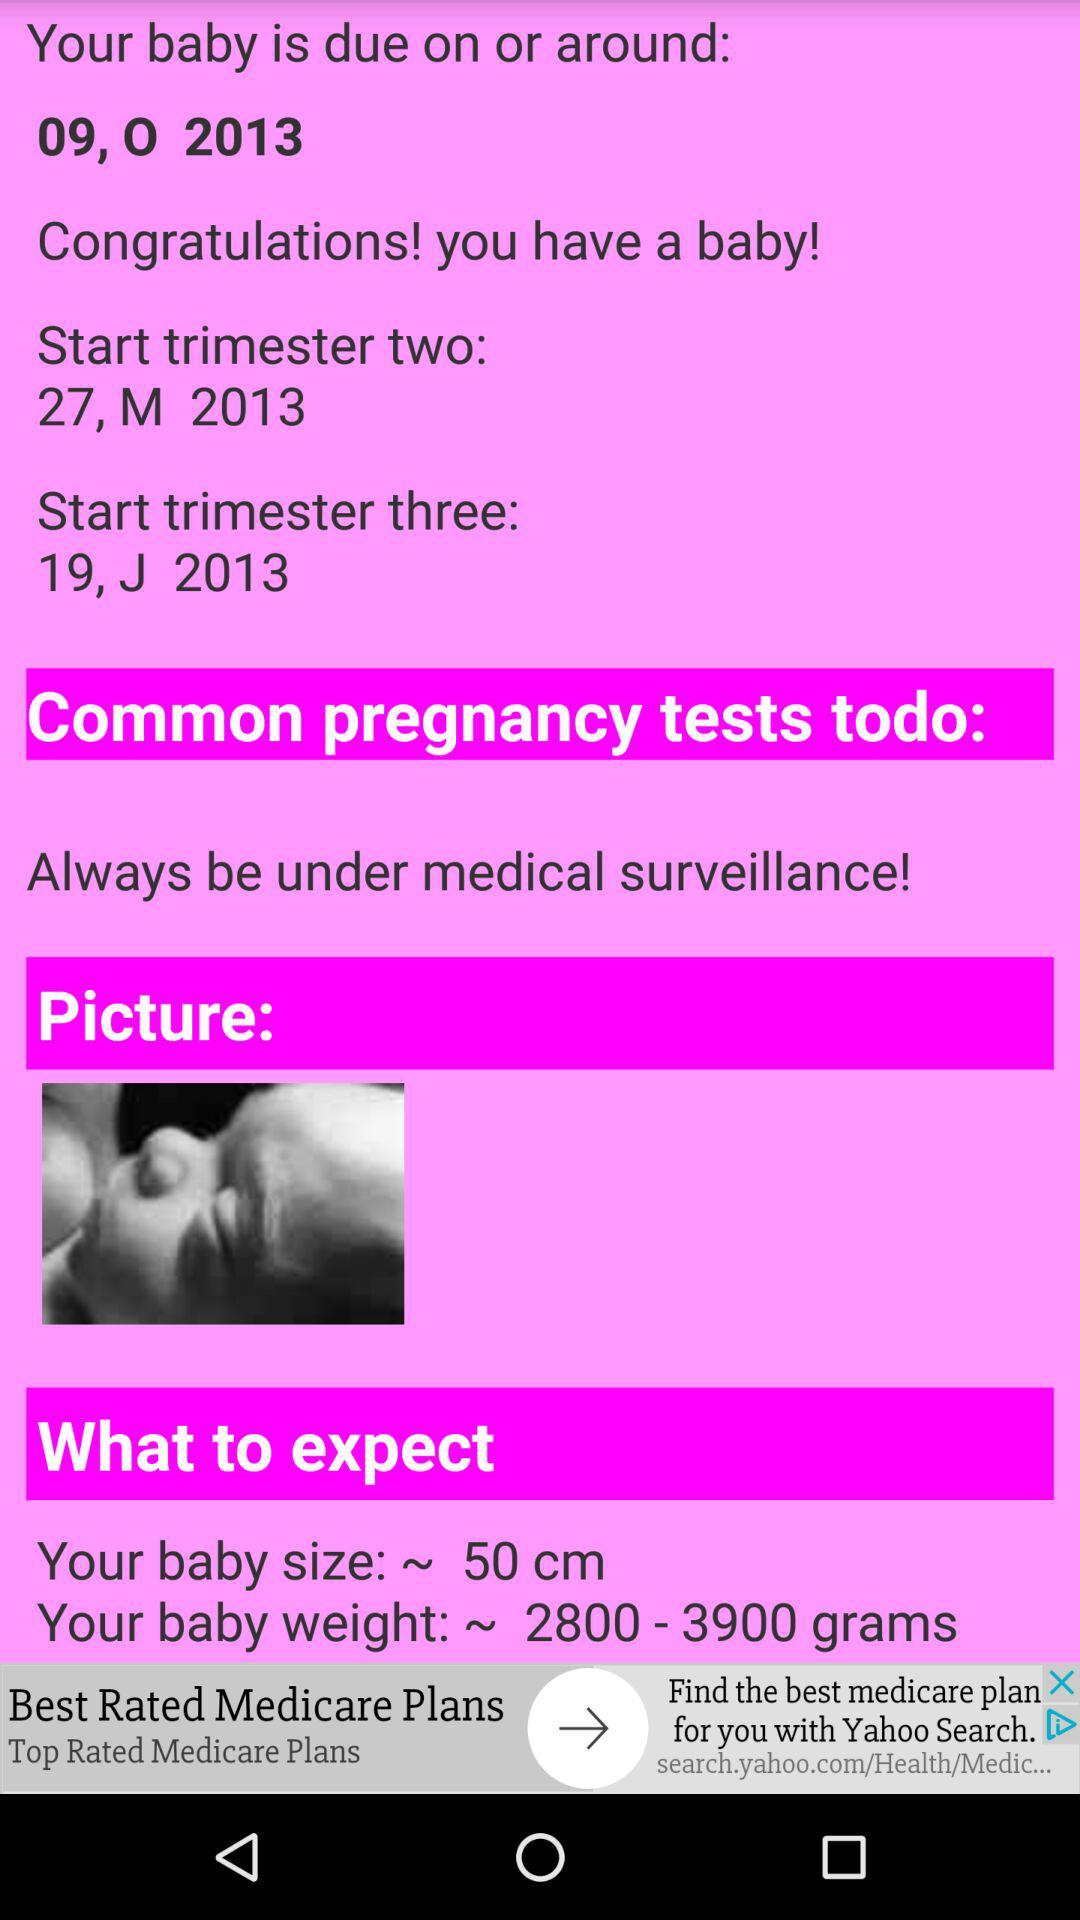What is the expected baby weight range? The expected baby weight ranges from 2800 to 3900 grams. 